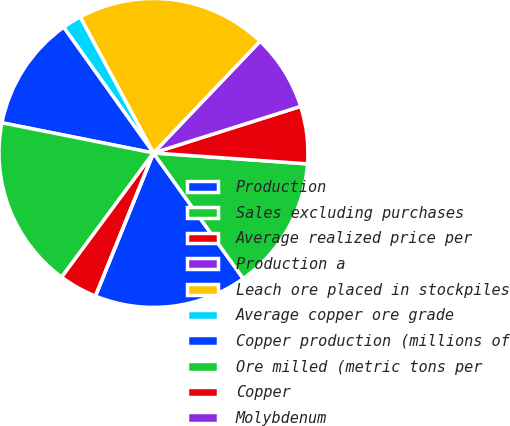<chart> <loc_0><loc_0><loc_500><loc_500><pie_chart><fcel>Production<fcel>Sales excluding purchases<fcel>Average realized price per<fcel>Production a<fcel>Leach ore placed in stockpiles<fcel>Average copper ore grade<fcel>Copper production (millions of<fcel>Ore milled (metric tons per<fcel>Copper<fcel>Molybdenum<nl><fcel>16.0%<fcel>14.0%<fcel>6.0%<fcel>8.0%<fcel>20.0%<fcel>2.0%<fcel>12.0%<fcel>18.0%<fcel>4.0%<fcel>0.0%<nl></chart> 